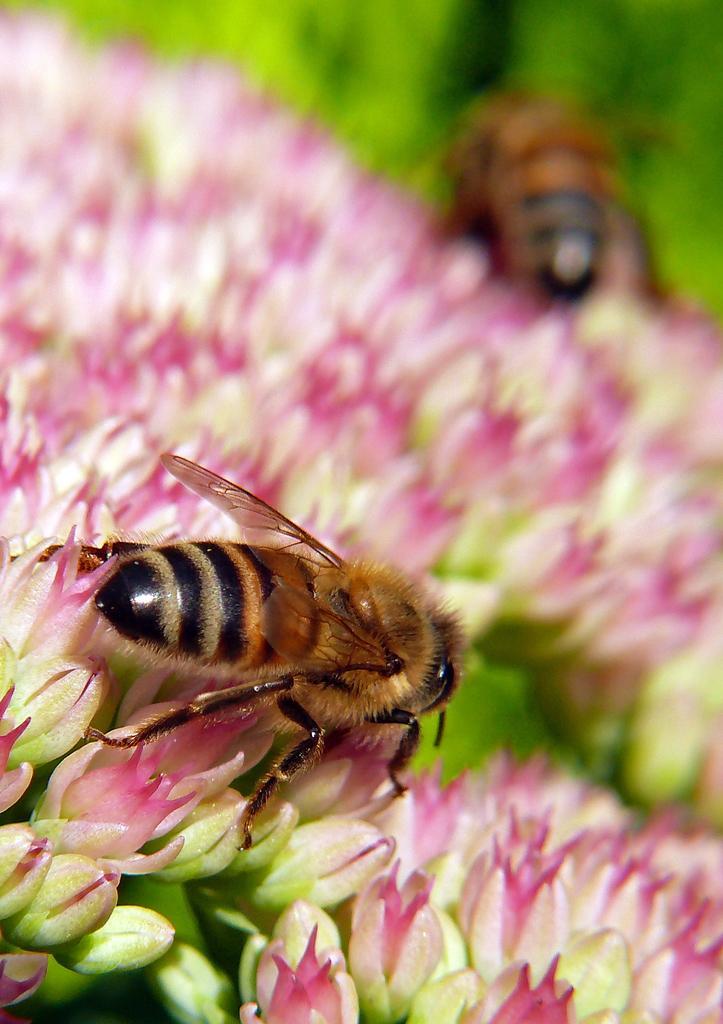Describe this image in one or two sentences. In this picture, we see the flowers and the buds in pink color. In front of the picture, we see a honey bee. In the background, we see a honey bee. In the background, it is green in color. This picture is blurred in the background. 